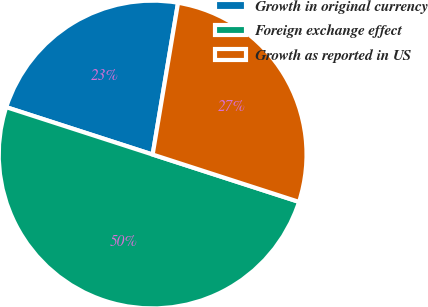Convert chart. <chart><loc_0><loc_0><loc_500><loc_500><pie_chart><fcel>Growth in original currency<fcel>Foreign exchange effect<fcel>Growth as reported in US<nl><fcel>22.66%<fcel>50.0%<fcel>27.34%<nl></chart> 